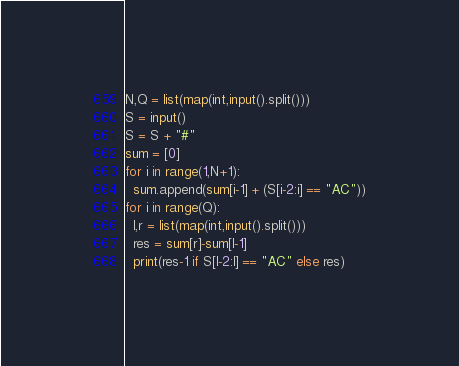Convert code to text. <code><loc_0><loc_0><loc_500><loc_500><_Python_>N,Q = list(map(int,input().split()))
S = input()
S = S + "#"
sum = [0]
for i in range(1,N+1):
  sum.append(sum[i-1] + (S[i-2:i] == "AC"))
for i in range(Q):
  l,r = list(map(int,input().split()))
  res = sum[r]-sum[l-1]
  print(res-1 if S[l-2:l] == "AC" else res)</code> 